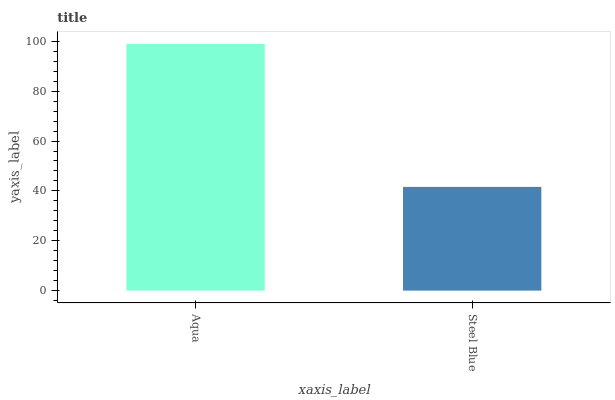Is Steel Blue the minimum?
Answer yes or no. Yes. Is Aqua the maximum?
Answer yes or no. Yes. Is Steel Blue the maximum?
Answer yes or no. No. Is Aqua greater than Steel Blue?
Answer yes or no. Yes. Is Steel Blue less than Aqua?
Answer yes or no. Yes. Is Steel Blue greater than Aqua?
Answer yes or no. No. Is Aqua less than Steel Blue?
Answer yes or no. No. Is Aqua the high median?
Answer yes or no. Yes. Is Steel Blue the low median?
Answer yes or no. Yes. Is Steel Blue the high median?
Answer yes or no. No. Is Aqua the low median?
Answer yes or no. No. 